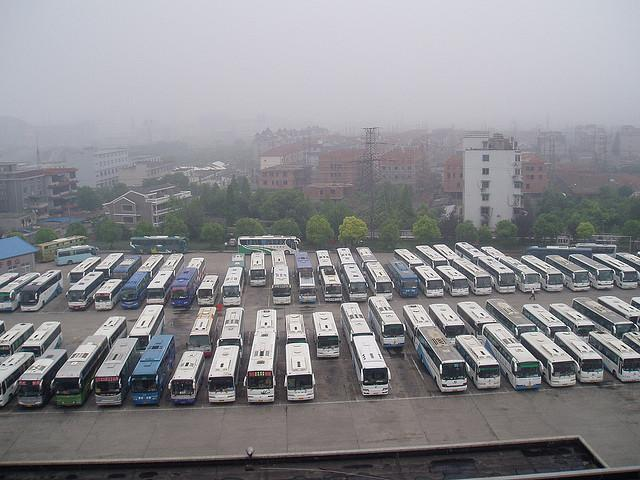What type of lot is this? bus 